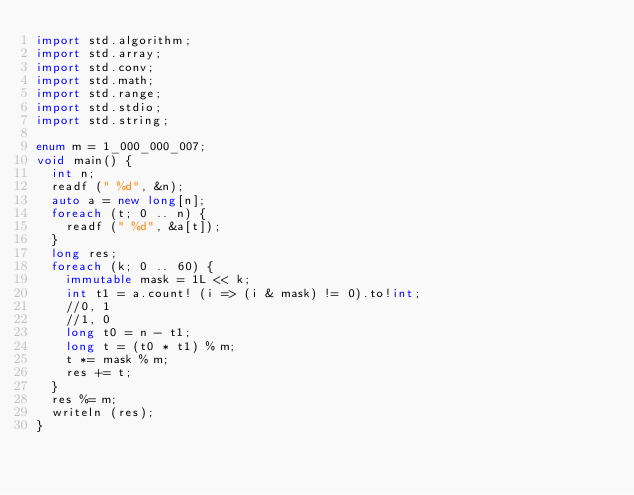<code> <loc_0><loc_0><loc_500><loc_500><_D_>import std.algorithm;
import std.array;
import std.conv;
import std.math;
import std.range;
import std.stdio;
import std.string;

enum m = 1_000_000_007;
void main() {
  int n;
  readf (" %d", &n);
  auto a = new long[n];
  foreach (t; 0 .. n) {
    readf (" %d", &a[t]);
  }
  long res;
  foreach (k; 0 .. 60) {
    immutable mask = 1L << k;
    int t1 = a.count! (i => (i & mask) != 0).to!int;
    //0, 1
    //1, 0
    long t0 = n - t1; 
    long t = (t0 * t1) % m;
    t *= mask % m;
    res += t;
  }
  res %= m;
  writeln (res);
}

</code> 